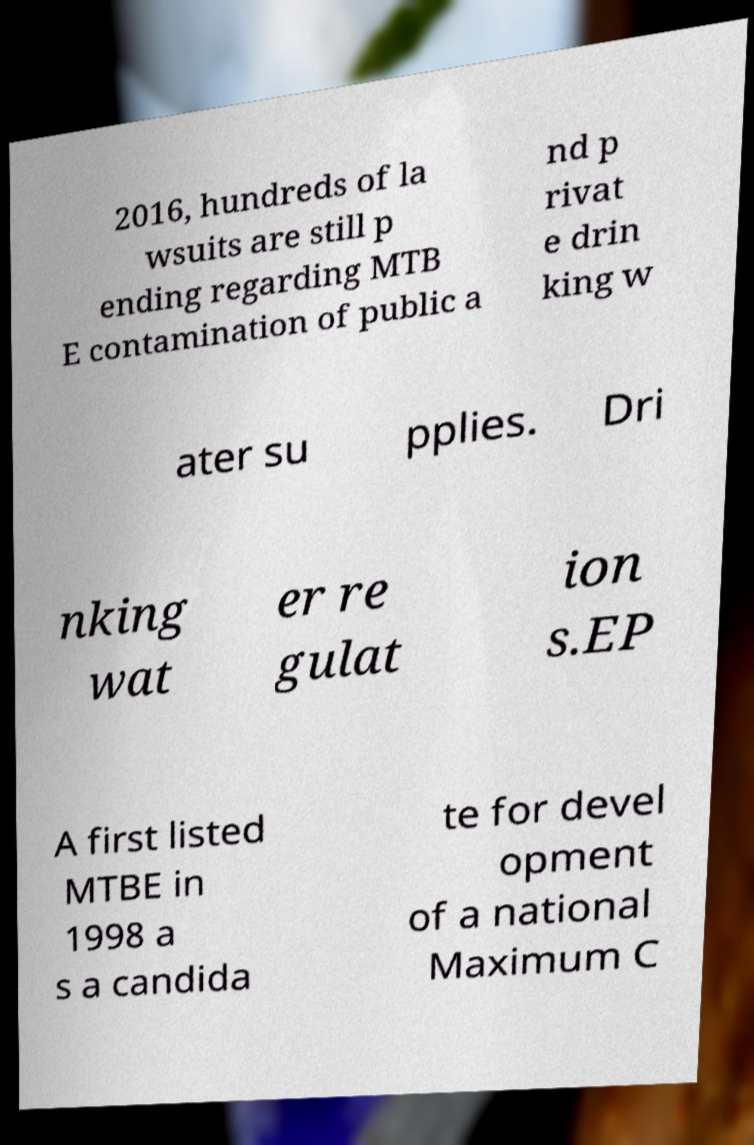There's text embedded in this image that I need extracted. Can you transcribe it verbatim? 2016, hundreds of la wsuits are still p ending regarding MTB E contamination of public a nd p rivat e drin king w ater su pplies. Dri nking wat er re gulat ion s.EP A first listed MTBE in 1998 a s a candida te for devel opment of a national Maximum C 